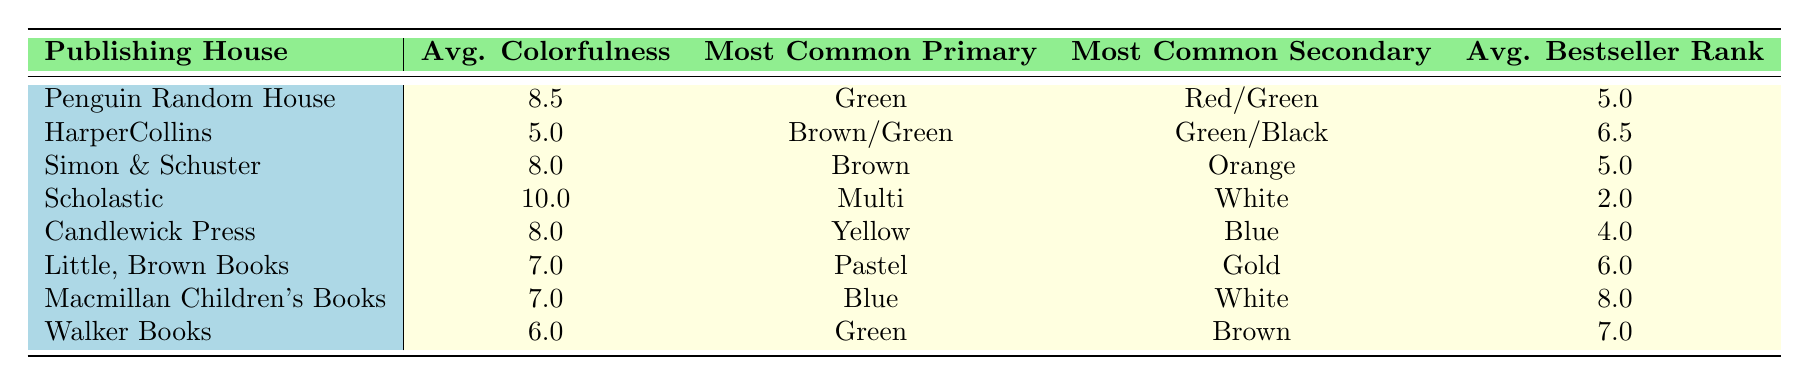What is the average colorfulness score for Penguin Random House? The table shows that the average colorfulness score for Penguin Random House is 8.5, which is explicitly stated in the "Avg. Colorfulness" column under the row for Penguin Random House.
Answer: 8.5 Which publishing house has the highest average bestseller rank? Looking at the "Avg. Bestseller Rank" column, Scholastic has the lowest value of 2.0, which corresponds to the highest ranking in the context of bestseller ranks (lower numbers indicate better ranks).
Answer: Scholastic Is there a publishing house that uses blue as its most common primary color? Yes, Macmillan Children's Books is noted in the table to have blue as its most common primary color, which can be found in the "Most Common Primary" column.
Answer: Yes What is the average colorfulness score of HarperCollins? The average colorfulness score listed for HarperCollins in the table is 5.0, found in the "Avg. Colorfulness" column.
Answer: 5.0 Which publishing house has a primary color of green and what is its average colorfulness score? Penguin Random House and HarperCollins both have green as a primary color. They have average colorfulness scores of 8.5 and 5.0 respectively. Therefore, the first publishing house listed with green as the primary color is Penguin Random House, with an average score of 8.5.
Answer: Penguin Random House, 8.5 Is the most common secondary color for Candlewick Press blue? Yes, the table indicates that blue is the most common secondary color for Candlewick Press as stated in the "Most Common Secondary" column.
Answer: Yes What is the average of the average colorfulness scores for all publishing houses? To calculate the average, sum the colorfulness scores: 8.5 + 5.0 + 8.0 + 10.0 + 8.0 + 7.0 + 7.0 + 6.0 = 60.0. There are 8 publishing houses, so the average is 60.0 / 8 = 7.5.
Answer: 7.5 Which publishing house has the most commonly used secondary color of white? Scholastic is the publishing house listed that has white as its most common secondary color according to the "Most Common Secondary" column.
Answer: Scholastic What is the difference in average bestseller rank between Scholastic and HarperCollins? Scholastic has an average bestseller rank of 2.0, and HarperCollins has an average rank of 6.5. The difference is calculated as 6.5 - 2.0 = 4.5.
Answer: 4.5 